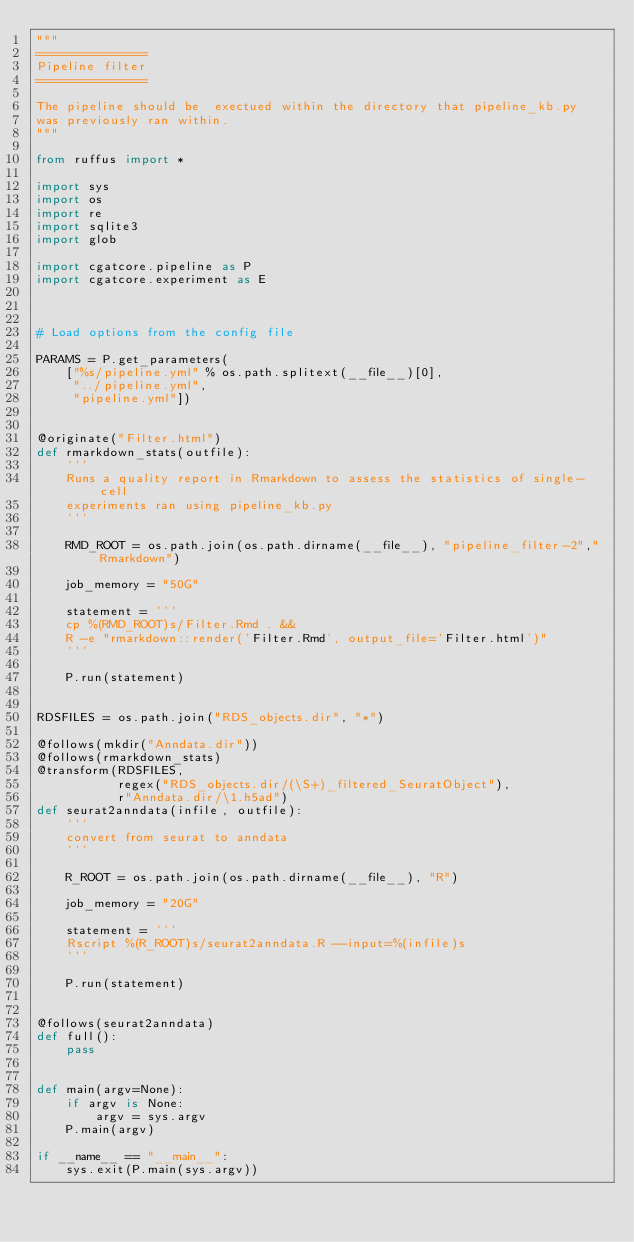<code> <loc_0><loc_0><loc_500><loc_500><_Python_>"""
===============
Pipeline filter
===============

The pipeline should be  exectued within the directory that pipeline_kb.py
was previously ran within.
"""

from ruffus import *

import sys
import os
import re
import sqlite3
import glob

import cgatcore.pipeline as P
import cgatcore.experiment as E



# Load options from the config file

PARAMS = P.get_parameters(
    ["%s/pipeline.yml" % os.path.splitext(__file__)[0],
     "../pipeline.yml",
     "pipeline.yml"])


@originate("Filter.html")
def rmarkdown_stats(outfile):
    '''
    Runs a quality report in Rmarkdown to assess the statistics of single-cell
    experiments ran using pipeline_kb.py
    '''

    RMD_ROOT = os.path.join(os.path.dirname(__file__), "pipeline_filter-2","Rmarkdown")

    job_memory = "50G"

    statement = '''
    cp %(RMD_ROOT)s/Filter.Rmd . &&
    R -e "rmarkdown::render('Filter.Rmd', output_file='Filter.html')"
    '''

    P.run(statement)


RDSFILES = os.path.join("RDS_objects.dir", "*")

@follows(mkdir("Anndata.dir"))
@follows(rmarkdown_stats)
@transform(RDSFILES,
           regex("RDS_objects.dir/(\S+)_filtered_SeuratObject"),
           r"Anndata.dir/\1.h5ad")
def seurat2anndata(infile, outfile):
    '''
    convert from seurat to anndata 
    '''

    R_ROOT = os.path.join(os.path.dirname(__file__), "R")

    job_memory = "20G"

    statement = '''
    Rscript %(R_ROOT)s/seurat2anndata.R --input=%(infile)s
    '''

    P.run(statement)


@follows(seurat2anndata)
def full():
    pass


def main(argv=None):
    if argv is None:
        argv = sys.argv
    P.main(argv)

if __name__ == "__main__":
    sys.exit(P.main(sys.argv))
</code> 